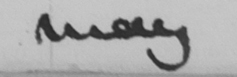Transcribe the text shown in this historical manuscript line. may 